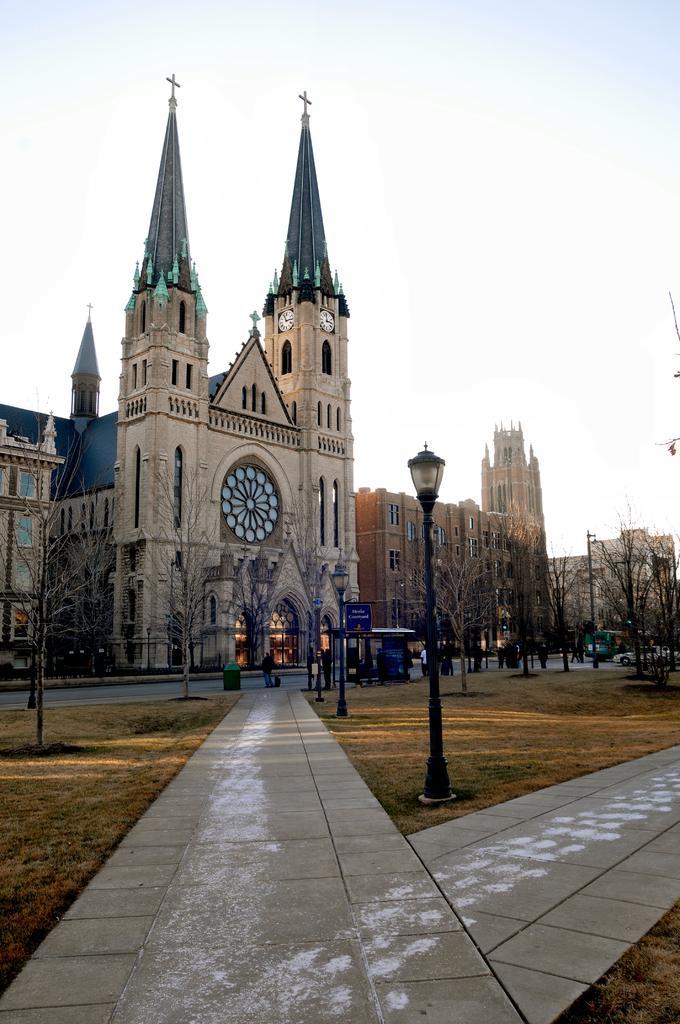How would you summarize this image in a sentence or two? In the center of the image we can see the sky, buildings, trees, poles, vehicles, few people and a few other objects. 